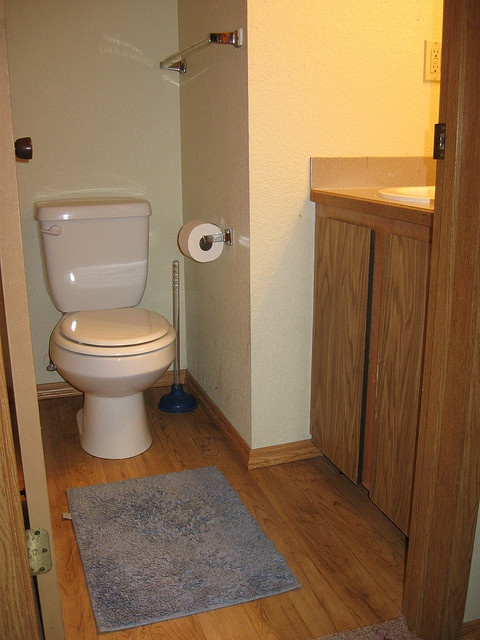Describe the objects in this image and their specific colors. I can see toilet in olive, darkgray, tan, and gray tones and sink in olive, orange, gold, khaki, and tan tones in this image. 